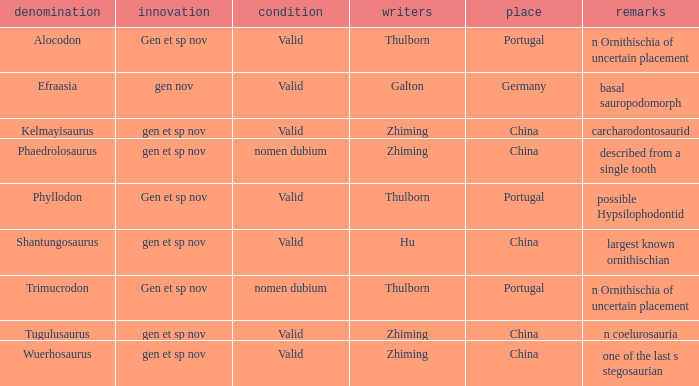What are the Notes of the dinosaur, whose Status is nomen dubium, and whose Location is China? Described from a single tooth. 